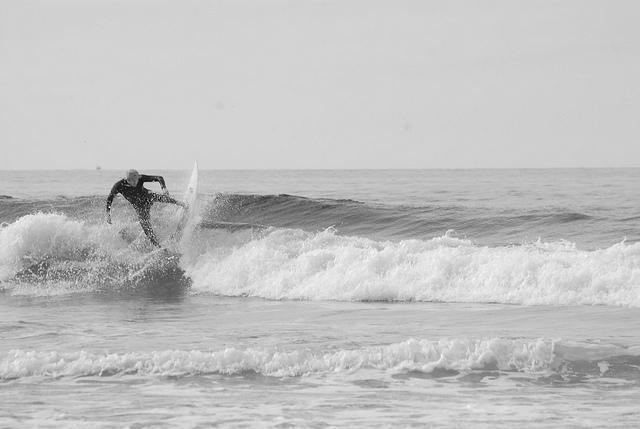How many birds are in front of the bear?
Give a very brief answer. 0. 